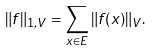<formula> <loc_0><loc_0><loc_500><loc_500>\| f \| _ { 1 , V } = \sum _ { x \in E } \| f ( x ) \| _ { V } .</formula> 